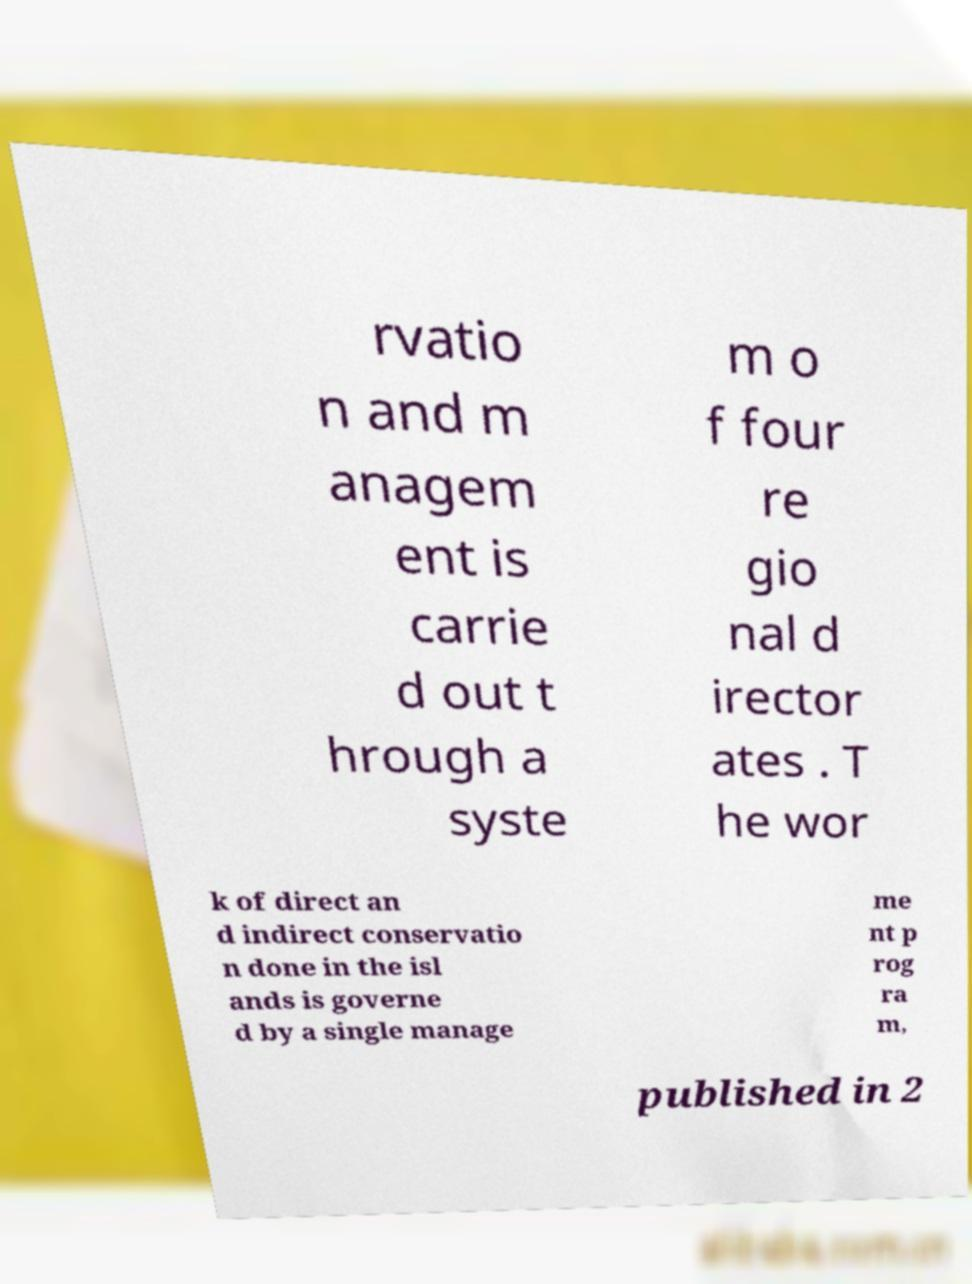For documentation purposes, I need the text within this image transcribed. Could you provide that? rvatio n and m anagem ent is carrie d out t hrough a syste m o f four re gio nal d irector ates . T he wor k of direct an d indirect conservatio n done in the isl ands is governe d by a single manage me nt p rog ra m, published in 2 